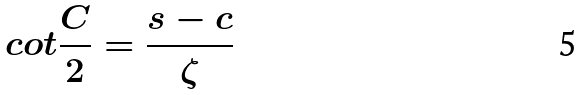Convert formula to latex. <formula><loc_0><loc_0><loc_500><loc_500>c o t \frac { C } { 2 } = \frac { s - c } { \zeta }</formula> 